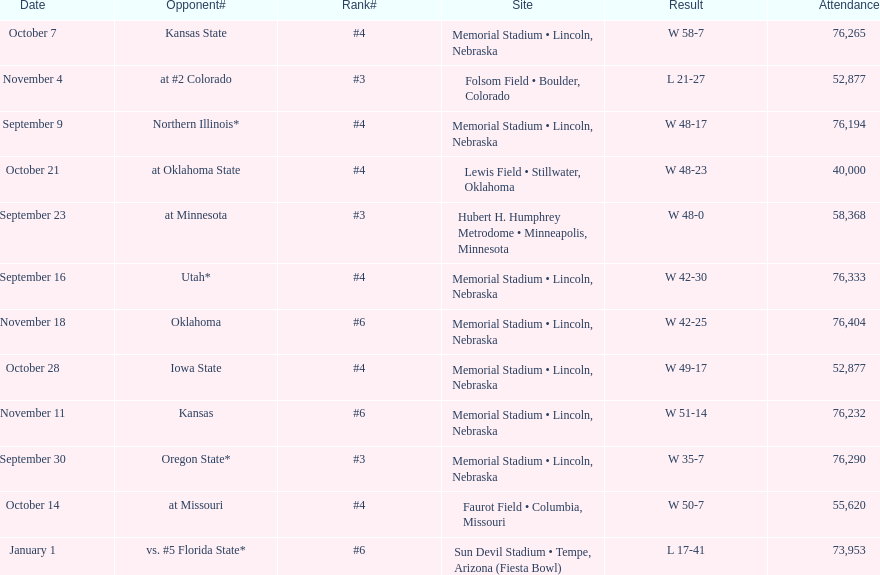What's the number of people who attended the oregon state game? 76,290. 